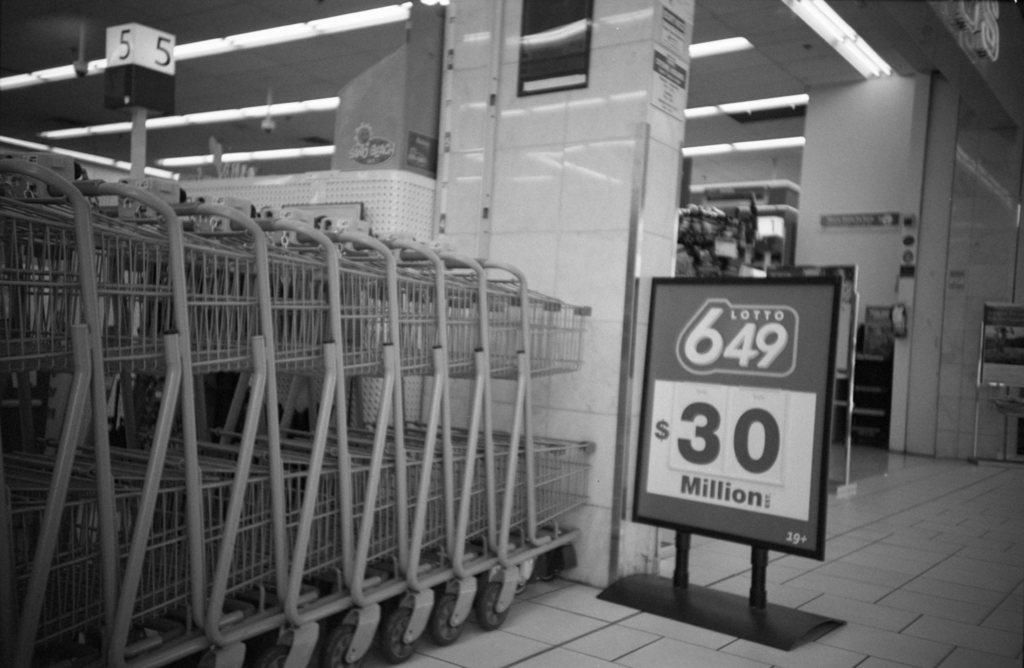<image>
Relay a brief, clear account of the picture shown. A series of shopping carts next to a Lotto for 30 million sign. 